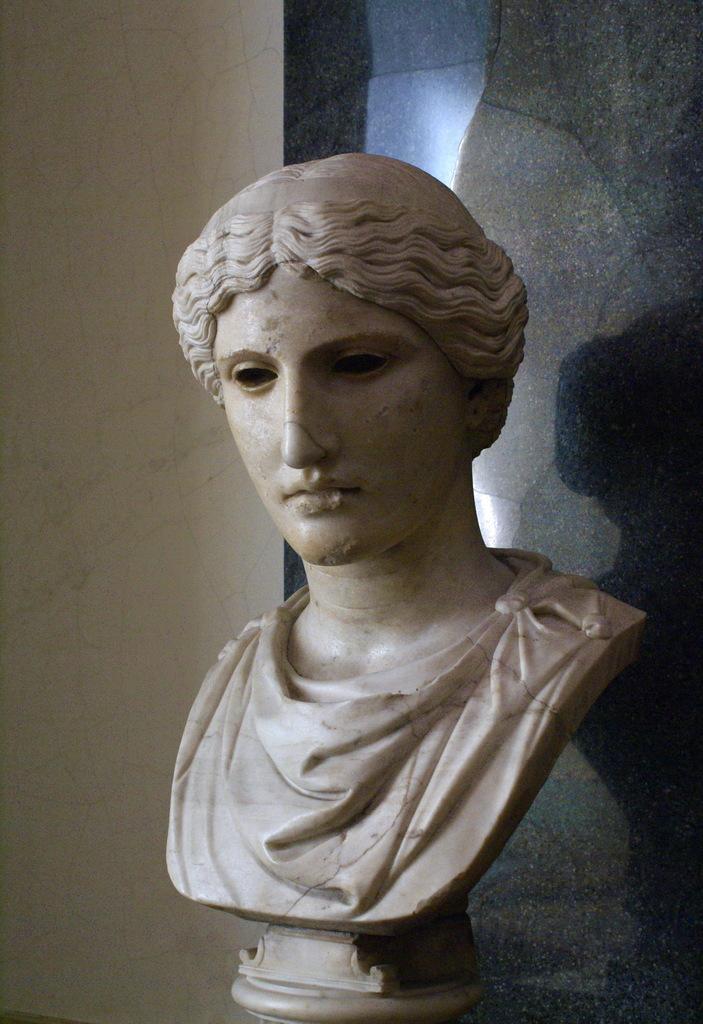How would you summarize this image in a sentence or two? In this image there is a sculpture of a person's face on the table. 